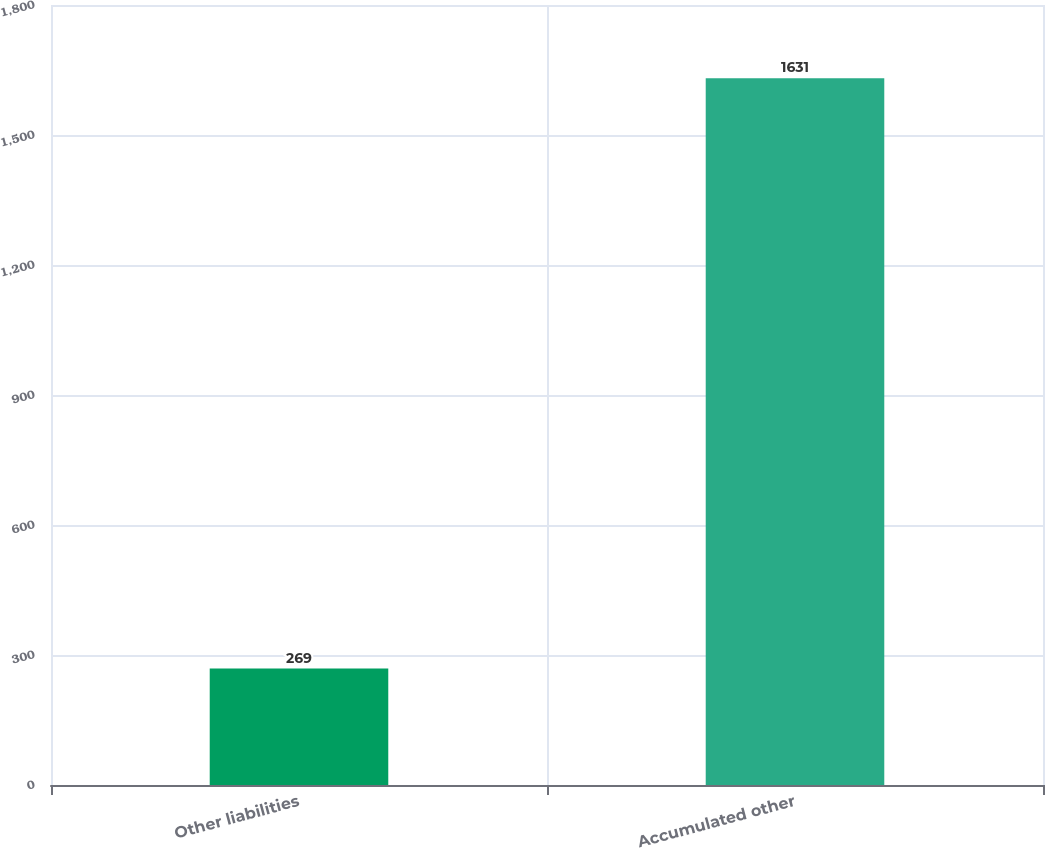Convert chart to OTSL. <chart><loc_0><loc_0><loc_500><loc_500><bar_chart><fcel>Other liabilities<fcel>Accumulated other<nl><fcel>269<fcel>1631<nl></chart> 